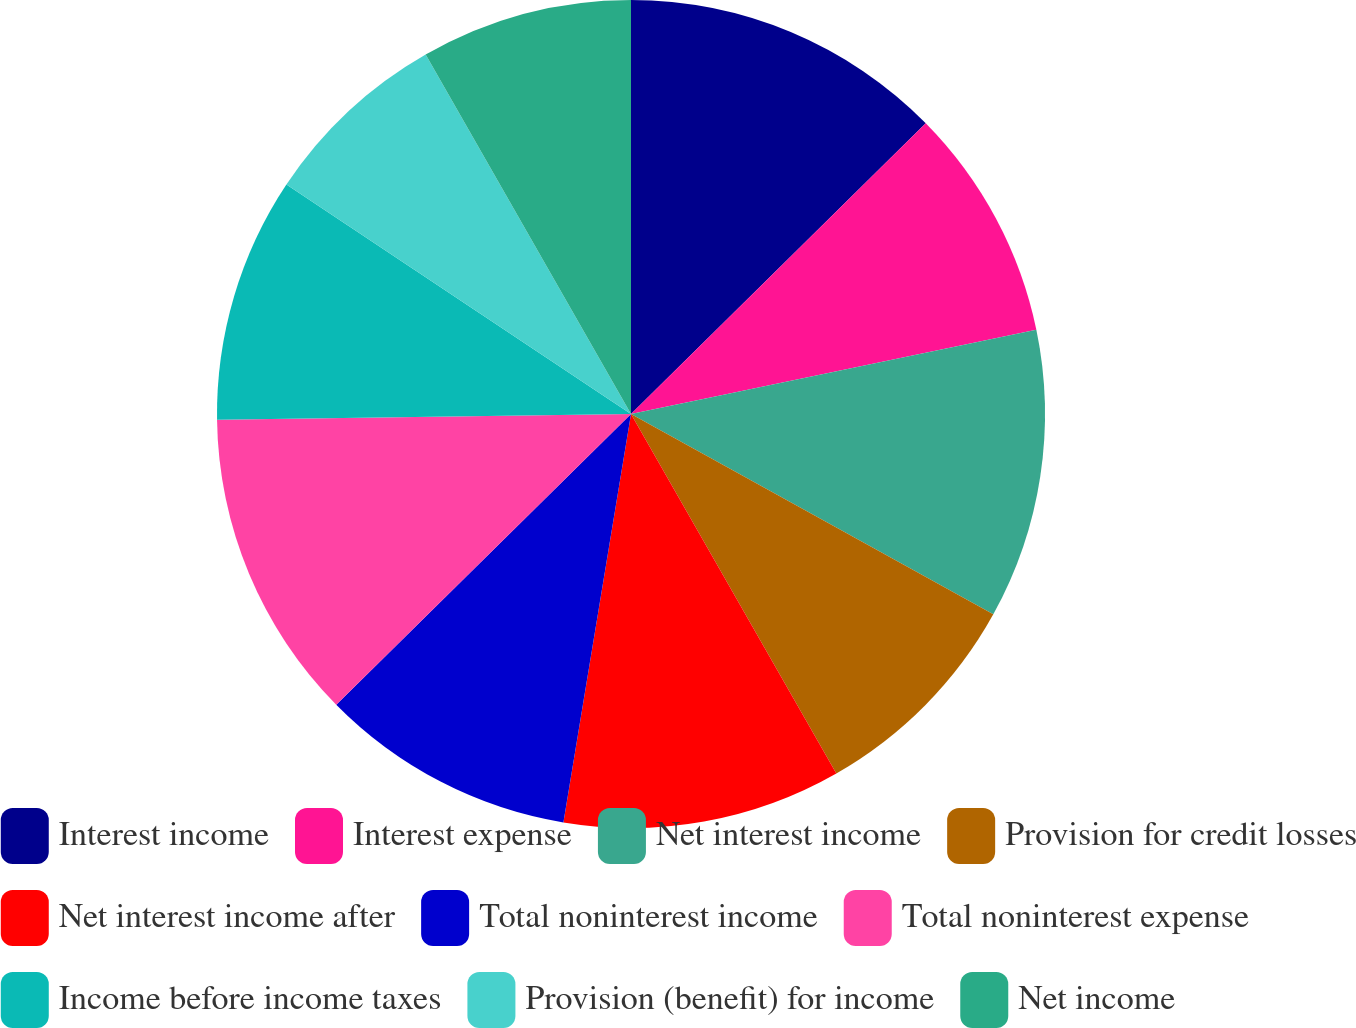Convert chart. <chart><loc_0><loc_0><loc_500><loc_500><pie_chart><fcel>Interest income<fcel>Interest expense<fcel>Net interest income<fcel>Provision for credit losses<fcel>Net interest income after<fcel>Total noninterest income<fcel>Total noninterest expense<fcel>Income before income taxes<fcel>Provision (benefit) for income<fcel>Net income<nl><fcel>12.61%<fcel>9.13%<fcel>11.3%<fcel>8.7%<fcel>10.87%<fcel>10.0%<fcel>12.17%<fcel>9.57%<fcel>7.39%<fcel>8.26%<nl></chart> 